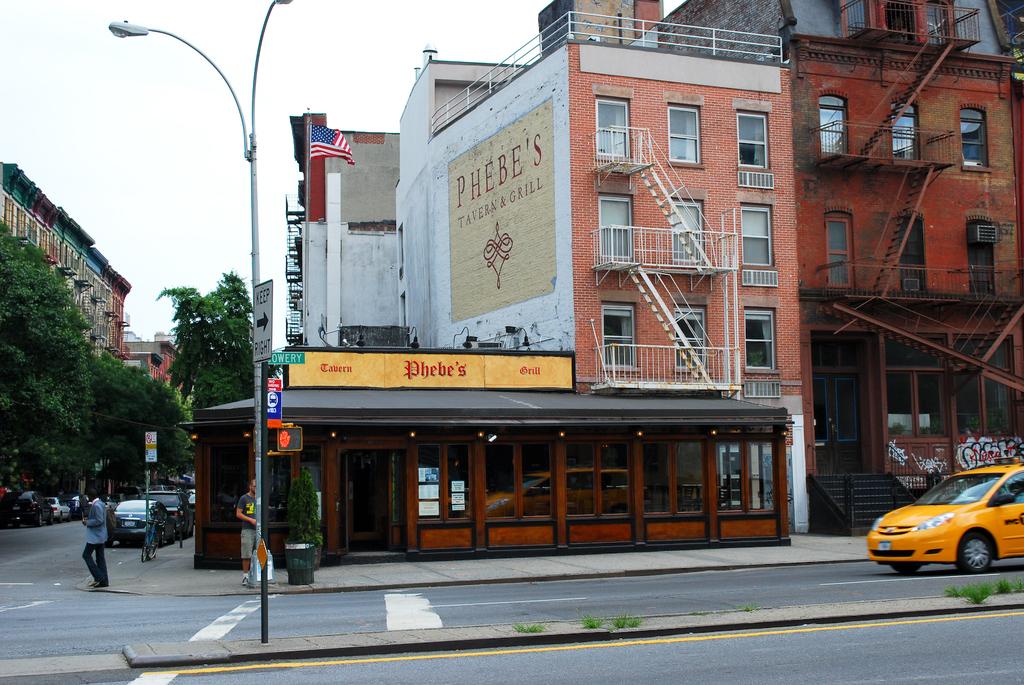What is the business name on the white side of the building?
Give a very brief answer. Phebe's. What is the name on the wall above the cafe?
Provide a short and direct response. Phebe's. 